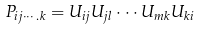<formula> <loc_0><loc_0><loc_500><loc_500>P _ { i j \cdots . k } = U _ { i j } U _ { j l } \cdot \cdot \cdot U _ { m k } U _ { k i }</formula> 